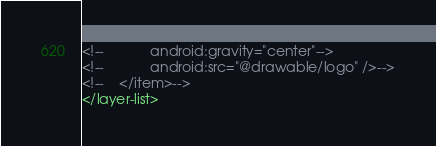Convert code to text. <code><loc_0><loc_0><loc_500><loc_500><_XML_><!--            android:gravity="center"-->
<!--            android:src="@drawable/logo" />-->
<!--    </item>-->
</layer-list>
</code> 